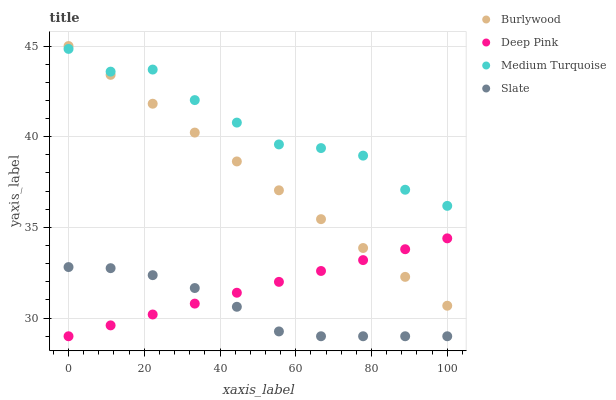Does Slate have the minimum area under the curve?
Answer yes or no. Yes. Does Medium Turquoise have the maximum area under the curve?
Answer yes or no. Yes. Does Deep Pink have the minimum area under the curve?
Answer yes or no. No. Does Deep Pink have the maximum area under the curve?
Answer yes or no. No. Is Burlywood the smoothest?
Answer yes or no. Yes. Is Medium Turquoise the roughest?
Answer yes or no. Yes. Is Slate the smoothest?
Answer yes or no. No. Is Slate the roughest?
Answer yes or no. No. Does Slate have the lowest value?
Answer yes or no. Yes. Does Medium Turquoise have the lowest value?
Answer yes or no. No. Does Burlywood have the highest value?
Answer yes or no. Yes. Does Deep Pink have the highest value?
Answer yes or no. No. Is Slate less than Burlywood?
Answer yes or no. Yes. Is Medium Turquoise greater than Deep Pink?
Answer yes or no. Yes. Does Deep Pink intersect Slate?
Answer yes or no. Yes. Is Deep Pink less than Slate?
Answer yes or no. No. Is Deep Pink greater than Slate?
Answer yes or no. No. Does Slate intersect Burlywood?
Answer yes or no. No. 